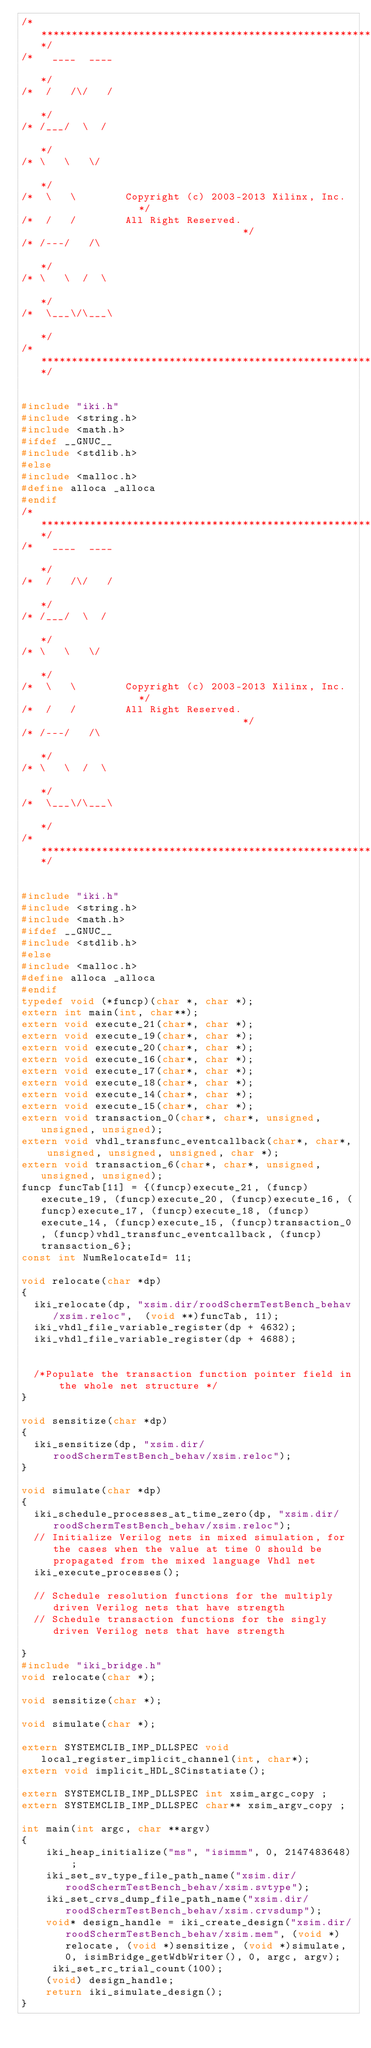Convert code to text. <code><loc_0><loc_0><loc_500><loc_500><_C_>/**********************************************************************/
/*   ____  ____                                                       */
/*  /   /\/   /                                                       */
/* /___/  \  /                                                        */
/* \   \   \/                                                         */
/*  \   \        Copyright (c) 2003-2013 Xilinx, Inc.                 */
/*  /   /        All Right Reserved.                                  */
/* /---/   /\                                                         */
/* \   \  /  \                                                        */
/*  \___\/\___\                                                       */
/**********************************************************************/


#include "iki.h"
#include <string.h>
#include <math.h>
#ifdef __GNUC__
#include <stdlib.h>
#else
#include <malloc.h>
#define alloca _alloca
#endif
/**********************************************************************/
/*   ____  ____                                                       */
/*  /   /\/   /                                                       */
/* /___/  \  /                                                        */
/* \   \   \/                                                         */
/*  \   \        Copyright (c) 2003-2013 Xilinx, Inc.                 */
/*  /   /        All Right Reserved.                                  */
/* /---/   /\                                                         */
/* \   \  /  \                                                        */
/*  \___\/\___\                                                       */
/**********************************************************************/


#include "iki.h"
#include <string.h>
#include <math.h>
#ifdef __GNUC__
#include <stdlib.h>
#else
#include <malloc.h>
#define alloca _alloca
#endif
typedef void (*funcp)(char *, char *);
extern int main(int, char**);
extern void execute_21(char*, char *);
extern void execute_19(char*, char *);
extern void execute_20(char*, char *);
extern void execute_16(char*, char *);
extern void execute_17(char*, char *);
extern void execute_18(char*, char *);
extern void execute_14(char*, char *);
extern void execute_15(char*, char *);
extern void transaction_0(char*, char*, unsigned, unsigned, unsigned);
extern void vhdl_transfunc_eventcallback(char*, char*, unsigned, unsigned, unsigned, char *);
extern void transaction_6(char*, char*, unsigned, unsigned, unsigned);
funcp funcTab[11] = {(funcp)execute_21, (funcp)execute_19, (funcp)execute_20, (funcp)execute_16, (funcp)execute_17, (funcp)execute_18, (funcp)execute_14, (funcp)execute_15, (funcp)transaction_0, (funcp)vhdl_transfunc_eventcallback, (funcp)transaction_6};
const int NumRelocateId= 11;

void relocate(char *dp)
{
	iki_relocate(dp, "xsim.dir/roodSchermTestBench_behav/xsim.reloc",  (void **)funcTab, 11);
	iki_vhdl_file_variable_register(dp + 4632);
	iki_vhdl_file_variable_register(dp + 4688);


	/*Populate the transaction function pointer field in the whole net structure */
}

void sensitize(char *dp)
{
	iki_sensitize(dp, "xsim.dir/roodSchermTestBench_behav/xsim.reloc");
}

void simulate(char *dp)
{
	iki_schedule_processes_at_time_zero(dp, "xsim.dir/roodSchermTestBench_behav/xsim.reloc");
	// Initialize Verilog nets in mixed simulation, for the cases when the value at time 0 should be propagated from the mixed language Vhdl net
	iki_execute_processes();

	// Schedule resolution functions for the multiply driven Verilog nets that have strength
	// Schedule transaction functions for the singly driven Verilog nets that have strength

}
#include "iki_bridge.h"
void relocate(char *);

void sensitize(char *);

void simulate(char *);

extern SYSTEMCLIB_IMP_DLLSPEC void local_register_implicit_channel(int, char*);
extern void implicit_HDL_SCinstatiate();

extern SYSTEMCLIB_IMP_DLLSPEC int xsim_argc_copy ;
extern SYSTEMCLIB_IMP_DLLSPEC char** xsim_argv_copy ;

int main(int argc, char **argv)
{
    iki_heap_initialize("ms", "isimmm", 0, 2147483648) ;
    iki_set_sv_type_file_path_name("xsim.dir/roodSchermTestBench_behav/xsim.svtype");
    iki_set_crvs_dump_file_path_name("xsim.dir/roodSchermTestBench_behav/xsim.crvsdump");
    void* design_handle = iki_create_design("xsim.dir/roodSchermTestBench_behav/xsim.mem", (void *)relocate, (void *)sensitize, (void *)simulate, 0, isimBridge_getWdbWriter(), 0, argc, argv);
     iki_set_rc_trial_count(100);
    (void) design_handle;
    return iki_simulate_design();
}
</code> 